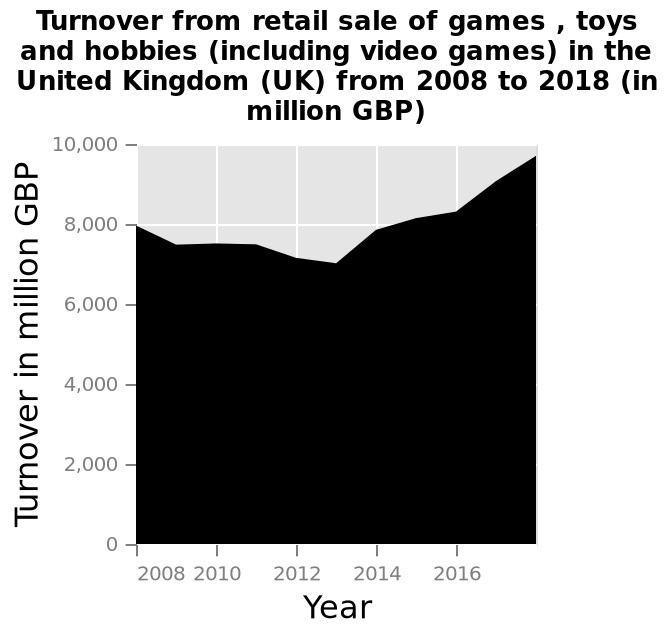<image>
please summary the statistics and relations of the chart The turnover in the UK for retail sales of games, toys and hobbies (including video games) was 8000million GBP in 2008 and dropped to 7000million GBP in 2013, before rising to 10000million GBP in 2018. Offer a thorough analysis of the image. Despite a slight decline in sales between 2008 to 2013, since then things have been going much better, with an overall sales increase of 2 million from 2008 to 2016. 